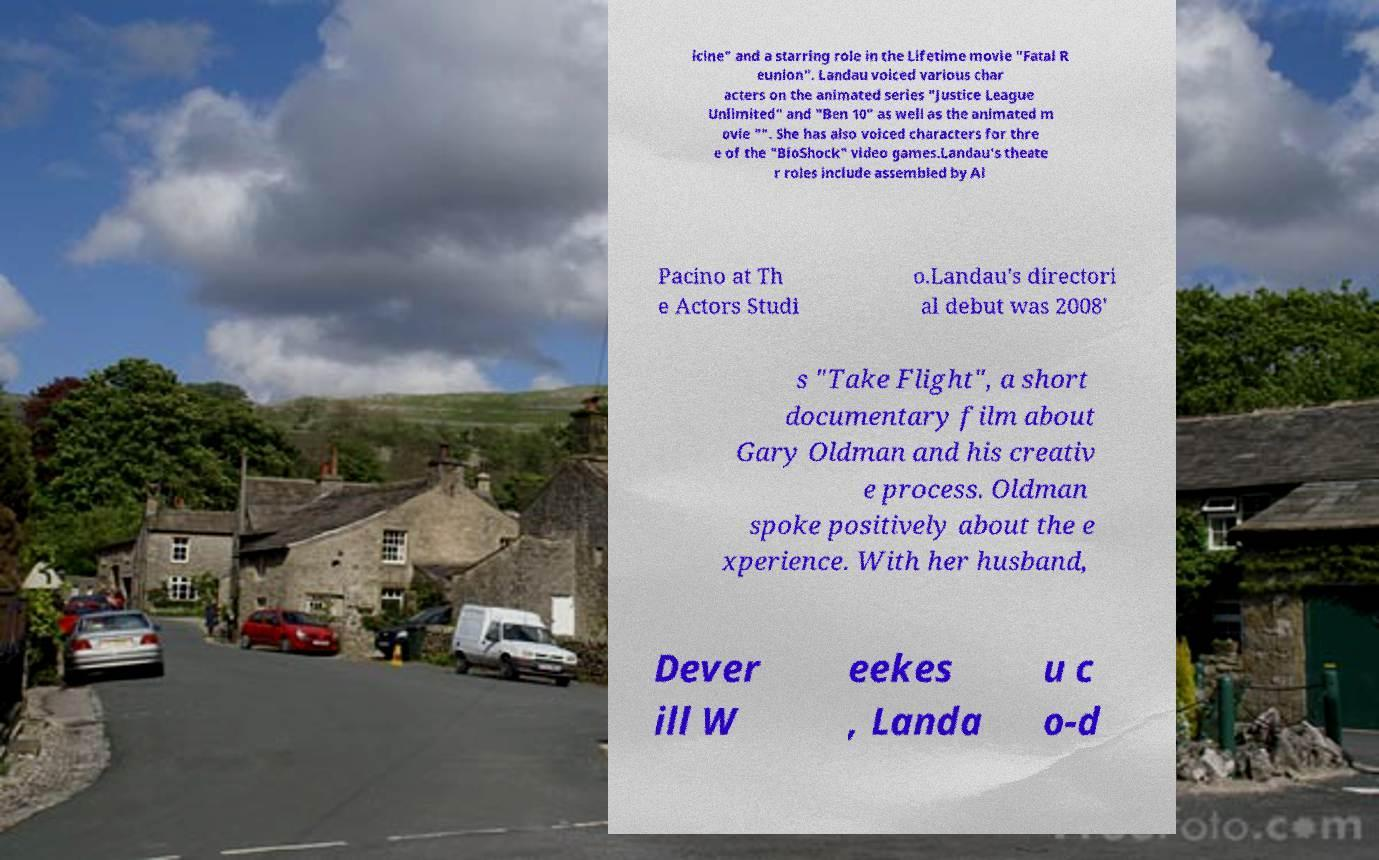Can you accurately transcribe the text from the provided image for me? icine" and a starring role in the Lifetime movie "Fatal R eunion". Landau voiced various char acters on the animated series "Justice League Unlimited" and "Ben 10" as well as the animated m ovie "". She has also voiced characters for thre e of the "BioShock" video games.Landau's theate r roles include assembled by Al Pacino at Th e Actors Studi o.Landau's directori al debut was 2008' s "Take Flight", a short documentary film about Gary Oldman and his creativ e process. Oldman spoke positively about the e xperience. With her husband, Dever ill W eekes , Landa u c o-d 